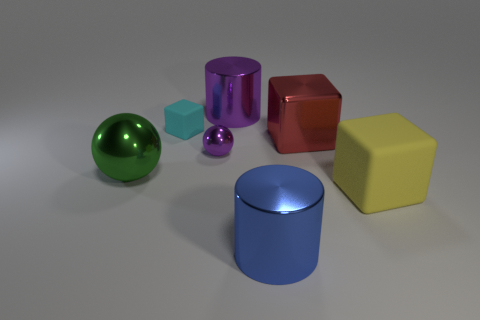There is a big yellow object that is the same shape as the red metal object; what material is it?
Offer a very short reply. Rubber. There is a large thing that is both on the left side of the blue metal thing and in front of the tiny cyan thing; what material is it?
Ensure brevity in your answer.  Metal. How many other objects are the same material as the large purple object?
Keep it short and to the point. 4. How many things have the same color as the tiny ball?
Offer a very short reply. 1. There is a matte cube that is to the left of the shiny thing that is in front of the cube in front of the tiny purple sphere; how big is it?
Ensure brevity in your answer.  Small. What number of rubber objects are either large brown blocks or cyan things?
Your answer should be compact. 1. There is a blue thing; is it the same shape as the object that is behind the small rubber cube?
Offer a terse response. Yes. Is the number of objects that are on the right side of the yellow matte cube greater than the number of big red metallic cubes left of the large red metallic object?
Offer a terse response. No. Is there any other thing of the same color as the tiny shiny object?
Your response must be concise. Yes. Is there a blue metallic thing that is to the left of the purple shiny object left of the big thing that is behind the small cyan rubber cube?
Your answer should be compact. No. 